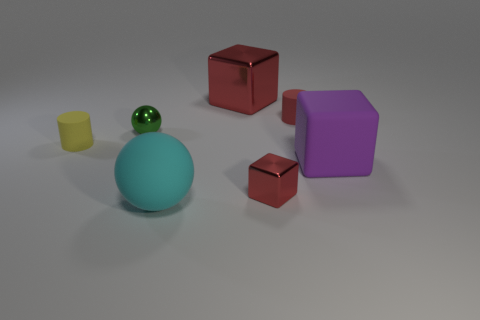Are there any patterns or symmetry observed in this arrangement? There isn't an obvious pattern or symmetry to the entirety of the object arrangement, but the two red cubes do provide a sense of symmetry due to their identical shape and color. 